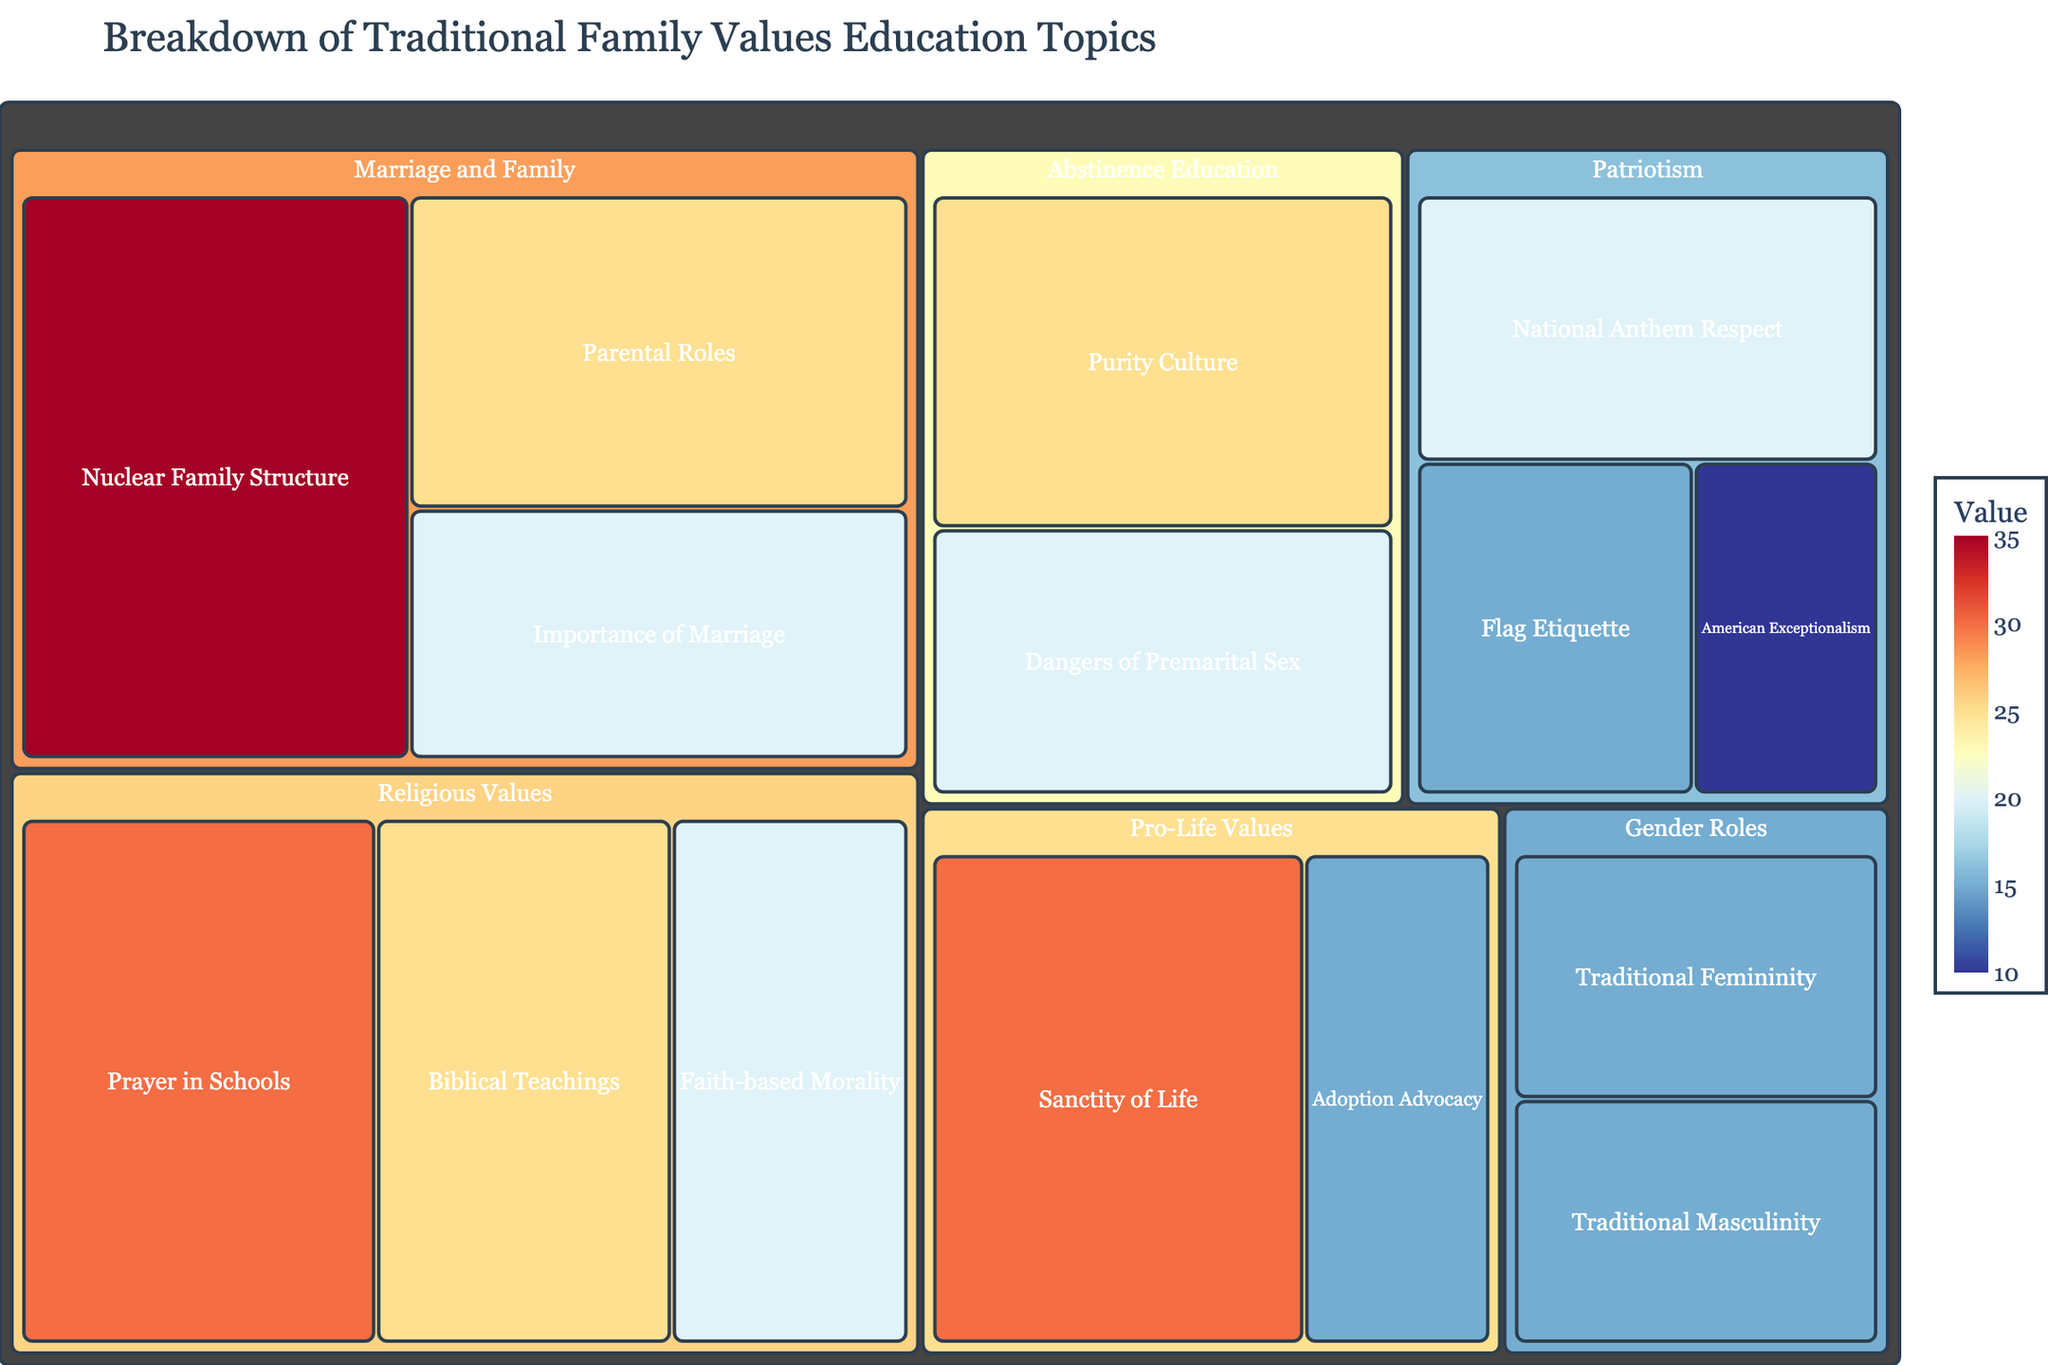What is the title of the figure? The title is displayed at the top of the figure. It is the text with the largest font size and is meant to summarize the content of the figure.
Answer: Breakdown of Traditional Family Values Education Topics Which subcategory has the highest value within the Pro-Life Values category? Locate the Pro-Life Values category in the Treemap and check the values of its subcategories. The subcategory with the highest value is the one with the largest visual block.
Answer: Sanctity of Life How many subcategories exist under the Marriage and Family category? Find the Marriage and Family category and count all the subcategories listed under it.
Answer: 3 What is the combined value of subcategories under the Gender Roles category? Locate the Gender Roles category and sum the values of both its subcategories (Traditional Masculinity and Traditional Femininity). Calculation: 15 + 15 = 30
Answer: 30 Which category has more subcategories: Patriotism or Abstinence Education? Compare the number of subcategories under the Patriotism and Abstinence Education categories.
Answer: Patriotism What is the average value of subcategories within the Religious Values category? Locate the Religious Values category and sum the values of its subcategories (Prayer in Schools, Biblical Teachings, Faith-based Morality). Then calculate the average by dividing the sum by the number of subcategories. Calculation: (30 + 25 + 20) / 3 = 75 / 3 = 25
Answer: 25 Which category has a higher total value: Marriage and Family or Patriotism? Sum the values of all subcategories under each category and compare the two totals. Calculation for Marriage and Family: 35 + 25 + 20 = 80. Calculation for Patriotism: 20 + 15 + 10 = 45.
Answer: Marriage and Family What is the smallest subcategory within the figure? Identify the subcategory with the smallest value in the entire Treemap.
Answer: American Exceptionalism How does the value of the Purity Culture subcategory compare to the Dangers of Premarital Sex subcategory? Locate both subcategories within Abstinence Education and compare their values. Purity Culture has a value of 25, and Dangers of Premarital Sex has a value of 20.
Answer: Purity Culture has a higher value Within Gender Roles, which subcategory holds the same value? Look at the Gender Roles category to find if any subcategories share the same value. Both Traditional Masculinity and Traditional Femininity have a value of 15.
Answer: Both have the same value 